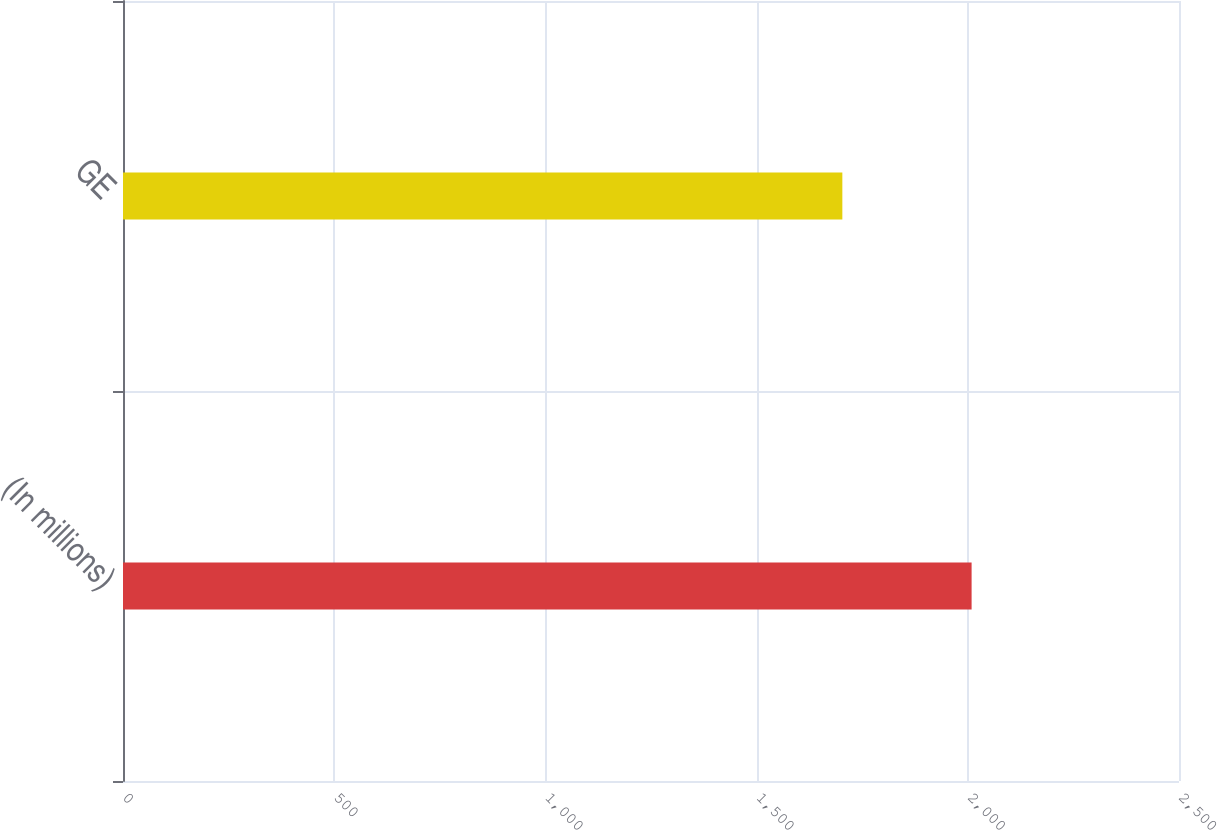Convert chart to OTSL. <chart><loc_0><loc_0><loc_500><loc_500><bar_chart><fcel>(In millions)<fcel>GE<nl><fcel>2009<fcel>1703<nl></chart> 